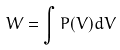Convert formula to latex. <formula><loc_0><loc_0><loc_500><loc_500>W = \int P ( V ) d V</formula> 